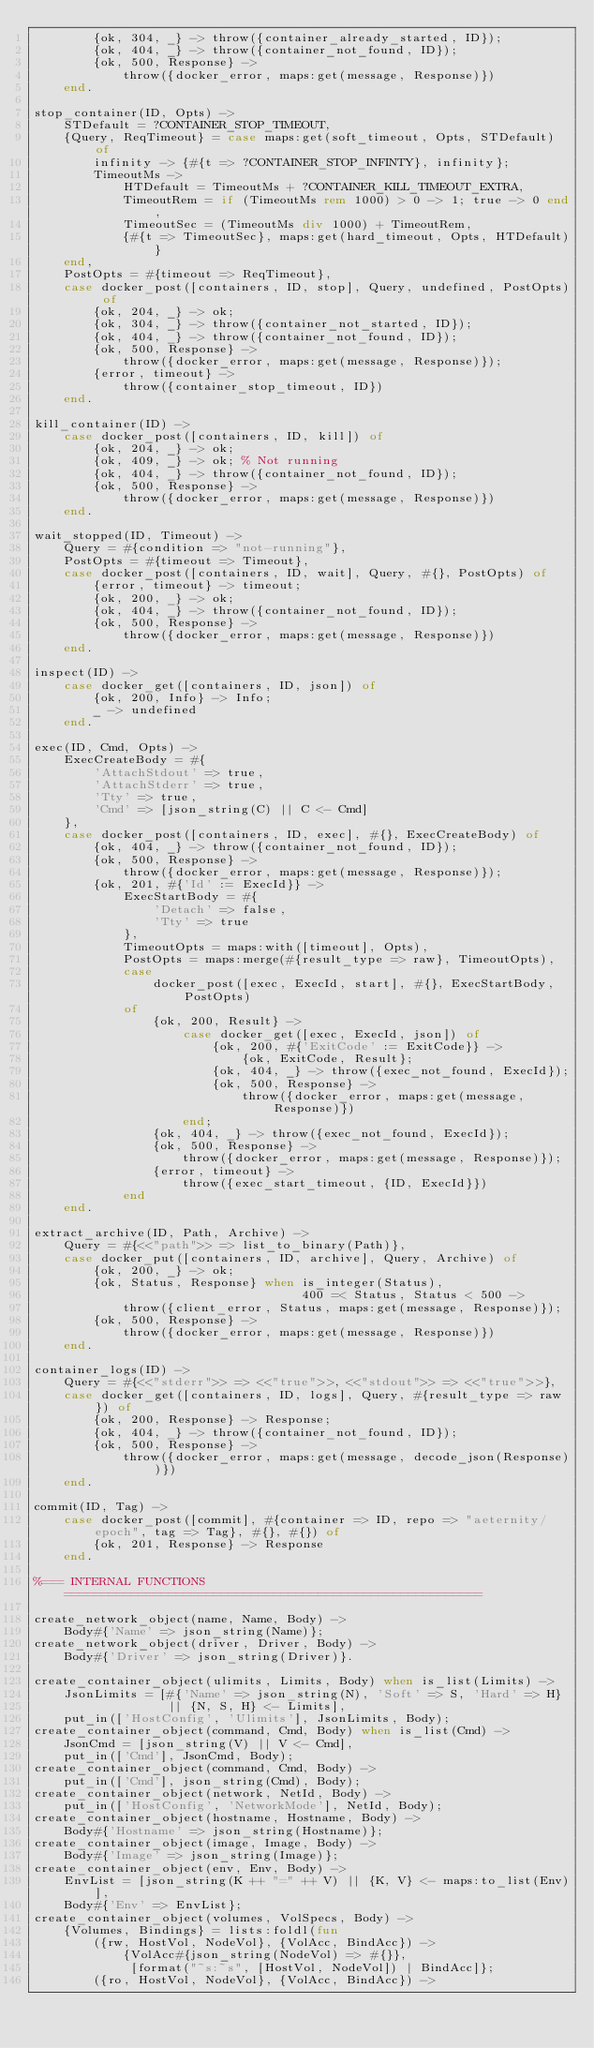Convert code to text. <code><loc_0><loc_0><loc_500><loc_500><_Erlang_>        {ok, 304, _} -> throw({container_already_started, ID});
        {ok, 404, _} -> throw({container_not_found, ID});
        {ok, 500, Response} ->
            throw({docker_error, maps:get(message, Response)})
    end.

stop_container(ID, Opts) ->
    STDefault = ?CONTAINER_STOP_TIMEOUT,
    {Query, ReqTimeout} = case maps:get(soft_timeout, Opts, STDefault) of
        infinity -> {#{t => ?CONTAINER_STOP_INFINTY}, infinity};
        TimeoutMs ->
            HTDefault = TimeoutMs + ?CONTAINER_KILL_TIMEOUT_EXTRA,
            TimeoutRem = if (TimeoutMs rem 1000) > 0 -> 1; true -> 0 end,
            TimeoutSec = (TimeoutMs div 1000) + TimeoutRem,
            {#{t => TimeoutSec}, maps:get(hard_timeout, Opts, HTDefault)}
    end,
    PostOpts = #{timeout => ReqTimeout},
    case docker_post([containers, ID, stop], Query, undefined, PostOpts) of
        {ok, 204, _} -> ok;
        {ok, 304, _} -> throw({container_not_started, ID});
        {ok, 404, _} -> throw({container_not_found, ID});
        {ok, 500, Response} ->
            throw({docker_error, maps:get(message, Response)});
        {error, timeout} ->
            throw({container_stop_timeout, ID})
    end.

kill_container(ID) ->
    case docker_post([containers, ID, kill]) of
        {ok, 204, _} -> ok;
        {ok, 409, _} -> ok; % Not running
        {ok, 404, _} -> throw({container_not_found, ID});
        {ok, 500, Response} ->
            throw({docker_error, maps:get(message, Response)})
    end.

wait_stopped(ID, Timeout) ->
    Query = #{condition => "not-running"},
    PostOpts = #{timeout => Timeout},
    case docker_post([containers, ID, wait], Query, #{}, PostOpts) of
        {error, timeout} -> timeout;
        {ok, 200, _} -> ok;
        {ok, 404, _} -> throw({container_not_found, ID});
        {ok, 500, Response} ->
            throw({docker_error, maps:get(message, Response)})
    end.

inspect(ID) ->
    case docker_get([containers, ID, json]) of
        {ok, 200, Info} -> Info;
        _ -> undefined
    end.

exec(ID, Cmd, Opts) ->
    ExecCreateBody = #{
        'AttachStdout' => true,
        'AttachStderr' => true,
        'Tty' => true,
        'Cmd' => [json_string(C) || C <- Cmd]
    },
    case docker_post([containers, ID, exec], #{}, ExecCreateBody) of
        {ok, 404, _} -> throw({container_not_found, ID});
        {ok, 500, Response} ->
            throw({docker_error, maps:get(message, Response)});
        {ok, 201, #{'Id' := ExecId}} ->
            ExecStartBody = #{
                'Detach' => false,
                'Tty' => true
            },
            TimeoutOpts = maps:with([timeout], Opts),
            PostOpts = maps:merge(#{result_type => raw}, TimeoutOpts),
            case
                docker_post([exec, ExecId, start], #{}, ExecStartBody, PostOpts)
            of
                {ok, 200, Result} ->
                    case docker_get([exec, ExecId, json]) of
                        {ok, 200, #{'ExitCode' := ExitCode}} ->
                            {ok, ExitCode, Result};
                        {ok, 404, _} -> throw({exec_not_found, ExecId});
                        {ok, 500, Response} ->
                            throw({docker_error, maps:get(message, Response)})
                    end;
                {ok, 404, _} -> throw({exec_not_found, ExecId});
                {ok, 500, Response} ->
                    throw({docker_error, maps:get(message, Response)});
                {error, timeout} ->
                    throw({exec_start_timeout, {ID, ExecId}})
            end
    end.

extract_archive(ID, Path, Archive) ->
    Query = #{<<"path">> => list_to_binary(Path)},
    case docker_put([containers, ID, archive], Query, Archive) of
        {ok, 200, _} -> ok;
        {ok, Status, Response} when is_integer(Status),
                                    400 =< Status, Status < 500 ->
            throw({client_error, Status, maps:get(message, Response)});
        {ok, 500, Response} ->
            throw({docker_error, maps:get(message, Response)})
    end.

container_logs(ID) ->
    Query = #{<<"stderr">> => <<"true">>, <<"stdout">> => <<"true">>},
    case docker_get([containers, ID, logs], Query, #{result_type => raw}) of
        {ok, 200, Response} -> Response;
        {ok, 404, _} -> throw({container_not_found, ID});
        {ok, 500, Response} ->
            throw({docker_error, maps:get(message, decode_json(Response))})
    end.

commit(ID, Tag) ->
    case docker_post([commit], #{container => ID, repo => "aeternity/epoch", tag => Tag}, #{}, #{}) of
        {ok, 201, Response} -> Response
    end.

%=== INTERNAL FUNCTIONS ========================================================

create_network_object(name, Name, Body) ->
    Body#{'Name' => json_string(Name)};
create_network_object(driver, Driver, Body) ->
    Body#{'Driver' => json_string(Driver)}.

create_container_object(ulimits, Limits, Body) when is_list(Limits) ->
    JsonLimits = [#{'Name' => json_string(N), 'Soft' => S, 'Hard' => H}
                  || {N, S, H} <- Limits],
    put_in(['HostConfig', 'Ulimits'], JsonLimits, Body);
create_container_object(command, Cmd, Body) when is_list(Cmd) ->
    JsonCmd = [json_string(V) || V <- Cmd],
    put_in(['Cmd'], JsonCmd, Body);
create_container_object(command, Cmd, Body) ->
    put_in(['Cmd'], json_string(Cmd), Body);
create_container_object(network, NetId, Body) ->
    put_in(['HostConfig', 'NetworkMode'], NetId, Body);
create_container_object(hostname, Hostname, Body) ->
    Body#{'Hostname' => json_string(Hostname)};
create_container_object(image, Image, Body) ->
    Body#{'Image' => json_string(Image)};
create_container_object(env, Env, Body) ->
    EnvList = [json_string(K ++ "=" ++ V) || {K, V} <- maps:to_list(Env)],
    Body#{'Env' => EnvList};
create_container_object(volumes, VolSpecs, Body) ->
    {Volumes, Bindings} = lists:foldl(fun
        ({rw, HostVol, NodeVol}, {VolAcc, BindAcc}) ->
            {VolAcc#{json_string(NodeVol) => #{}},
             [format("~s:~s", [HostVol, NodeVol]) | BindAcc]};
        ({ro, HostVol, NodeVol}, {VolAcc, BindAcc}) -></code> 